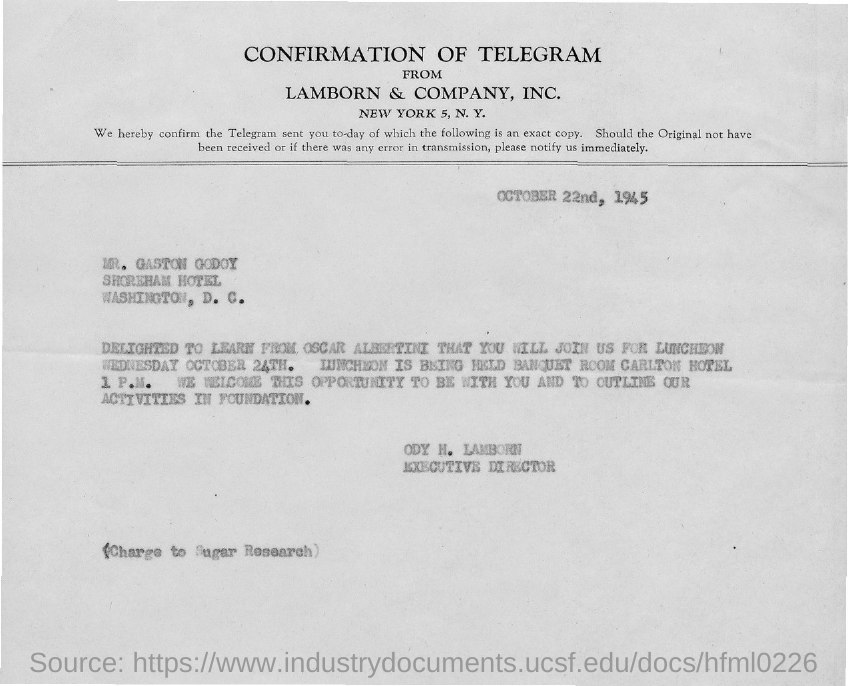From which company is the confirmation of telegram?
Provide a succinct answer. LAMBORN & COMPANY, INC. When is the document dated?
Your answer should be compact. OCTOBER 22nd, 1945. To whom is the document addressed?
Offer a terse response. MR. GASTON GODOY. Who is the sender?
Offer a terse response. ODY H. LAMBORN. When is the luncheon?
Provide a short and direct response. WEDNESDAY OCTOBER 24TH. At what time is the luncheon?
Your response must be concise. 1 P.M. Who has told that Mr. Gaston Godoy will join for luncheon?
Keep it short and to the point. OSCAR ALBERTINI. 